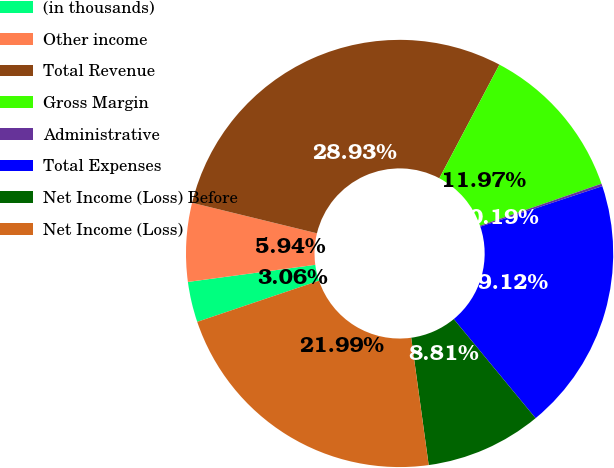Convert chart to OTSL. <chart><loc_0><loc_0><loc_500><loc_500><pie_chart><fcel>(in thousands)<fcel>Other income<fcel>Total Revenue<fcel>Gross Margin<fcel>Administrative<fcel>Total Expenses<fcel>Net Income (Loss) Before<fcel>Net Income (Loss)<nl><fcel>3.06%<fcel>5.94%<fcel>28.93%<fcel>11.97%<fcel>0.19%<fcel>19.12%<fcel>8.81%<fcel>21.99%<nl></chart> 